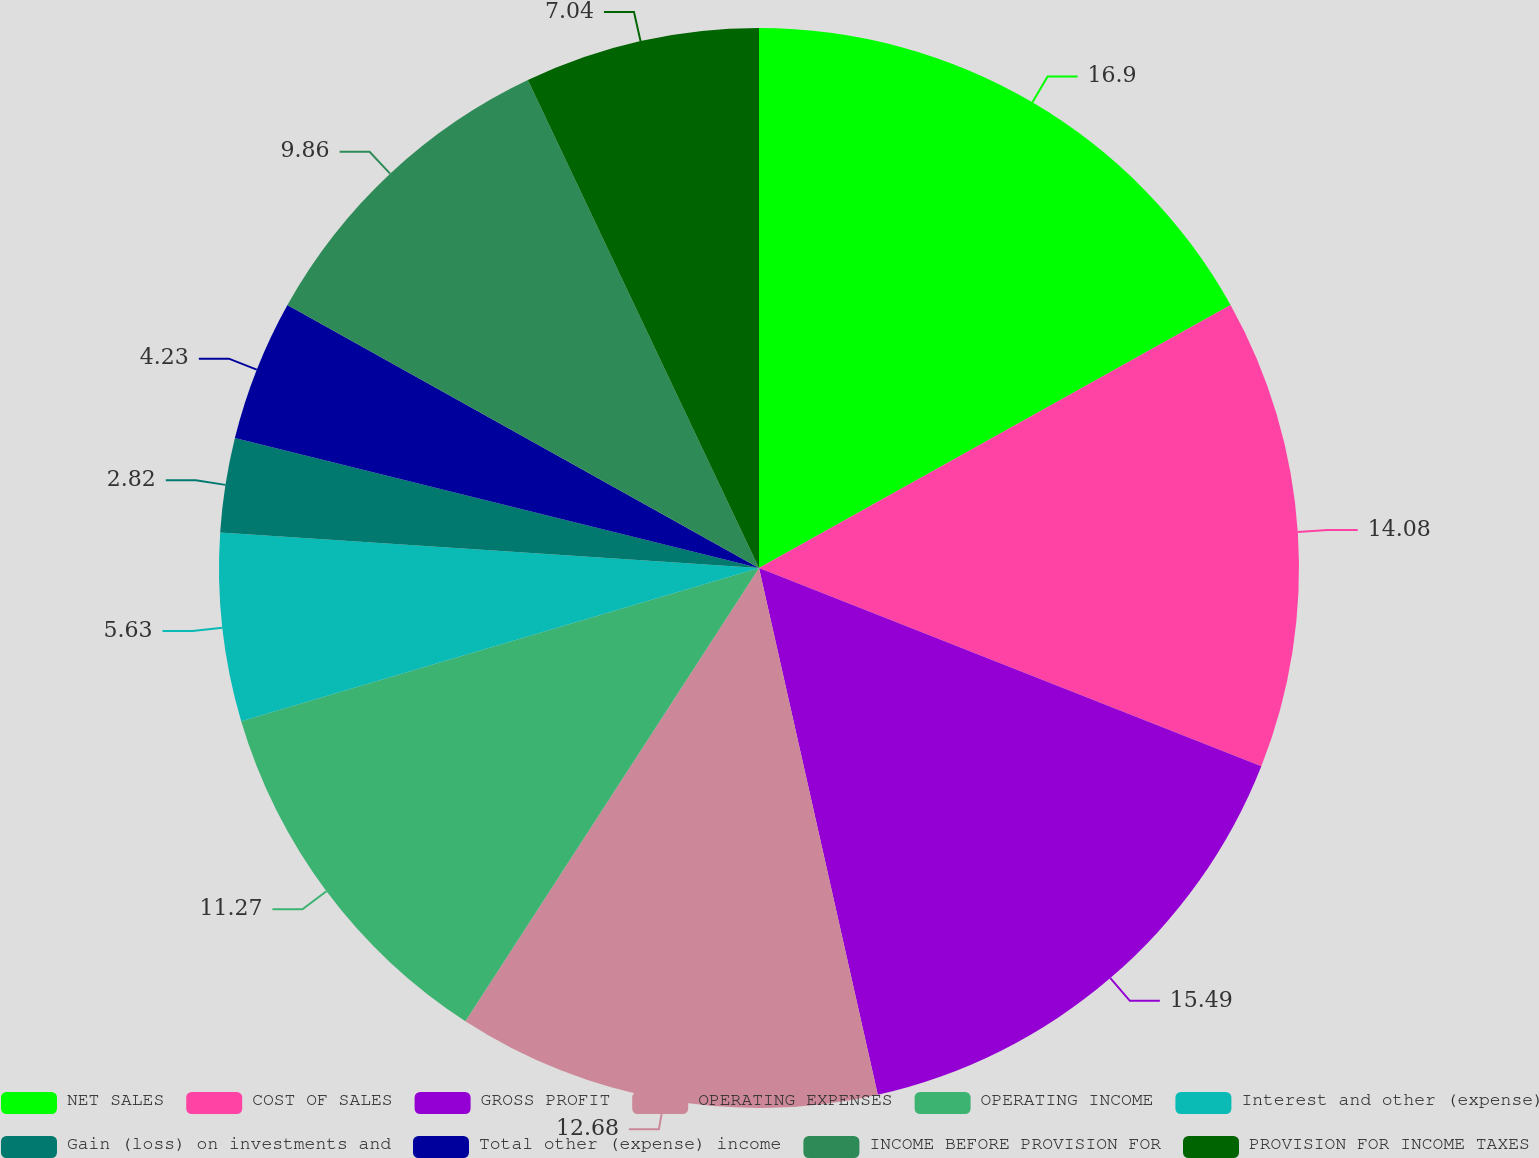Convert chart to OTSL. <chart><loc_0><loc_0><loc_500><loc_500><pie_chart><fcel>NET SALES<fcel>COST OF SALES<fcel>GROSS PROFIT<fcel>OPERATING EXPENSES<fcel>OPERATING INCOME<fcel>Interest and other (expense)<fcel>Gain (loss) on investments and<fcel>Total other (expense) income<fcel>INCOME BEFORE PROVISION FOR<fcel>PROVISION FOR INCOME TAXES<nl><fcel>16.9%<fcel>14.08%<fcel>15.49%<fcel>12.68%<fcel>11.27%<fcel>5.63%<fcel>2.82%<fcel>4.23%<fcel>9.86%<fcel>7.04%<nl></chart> 